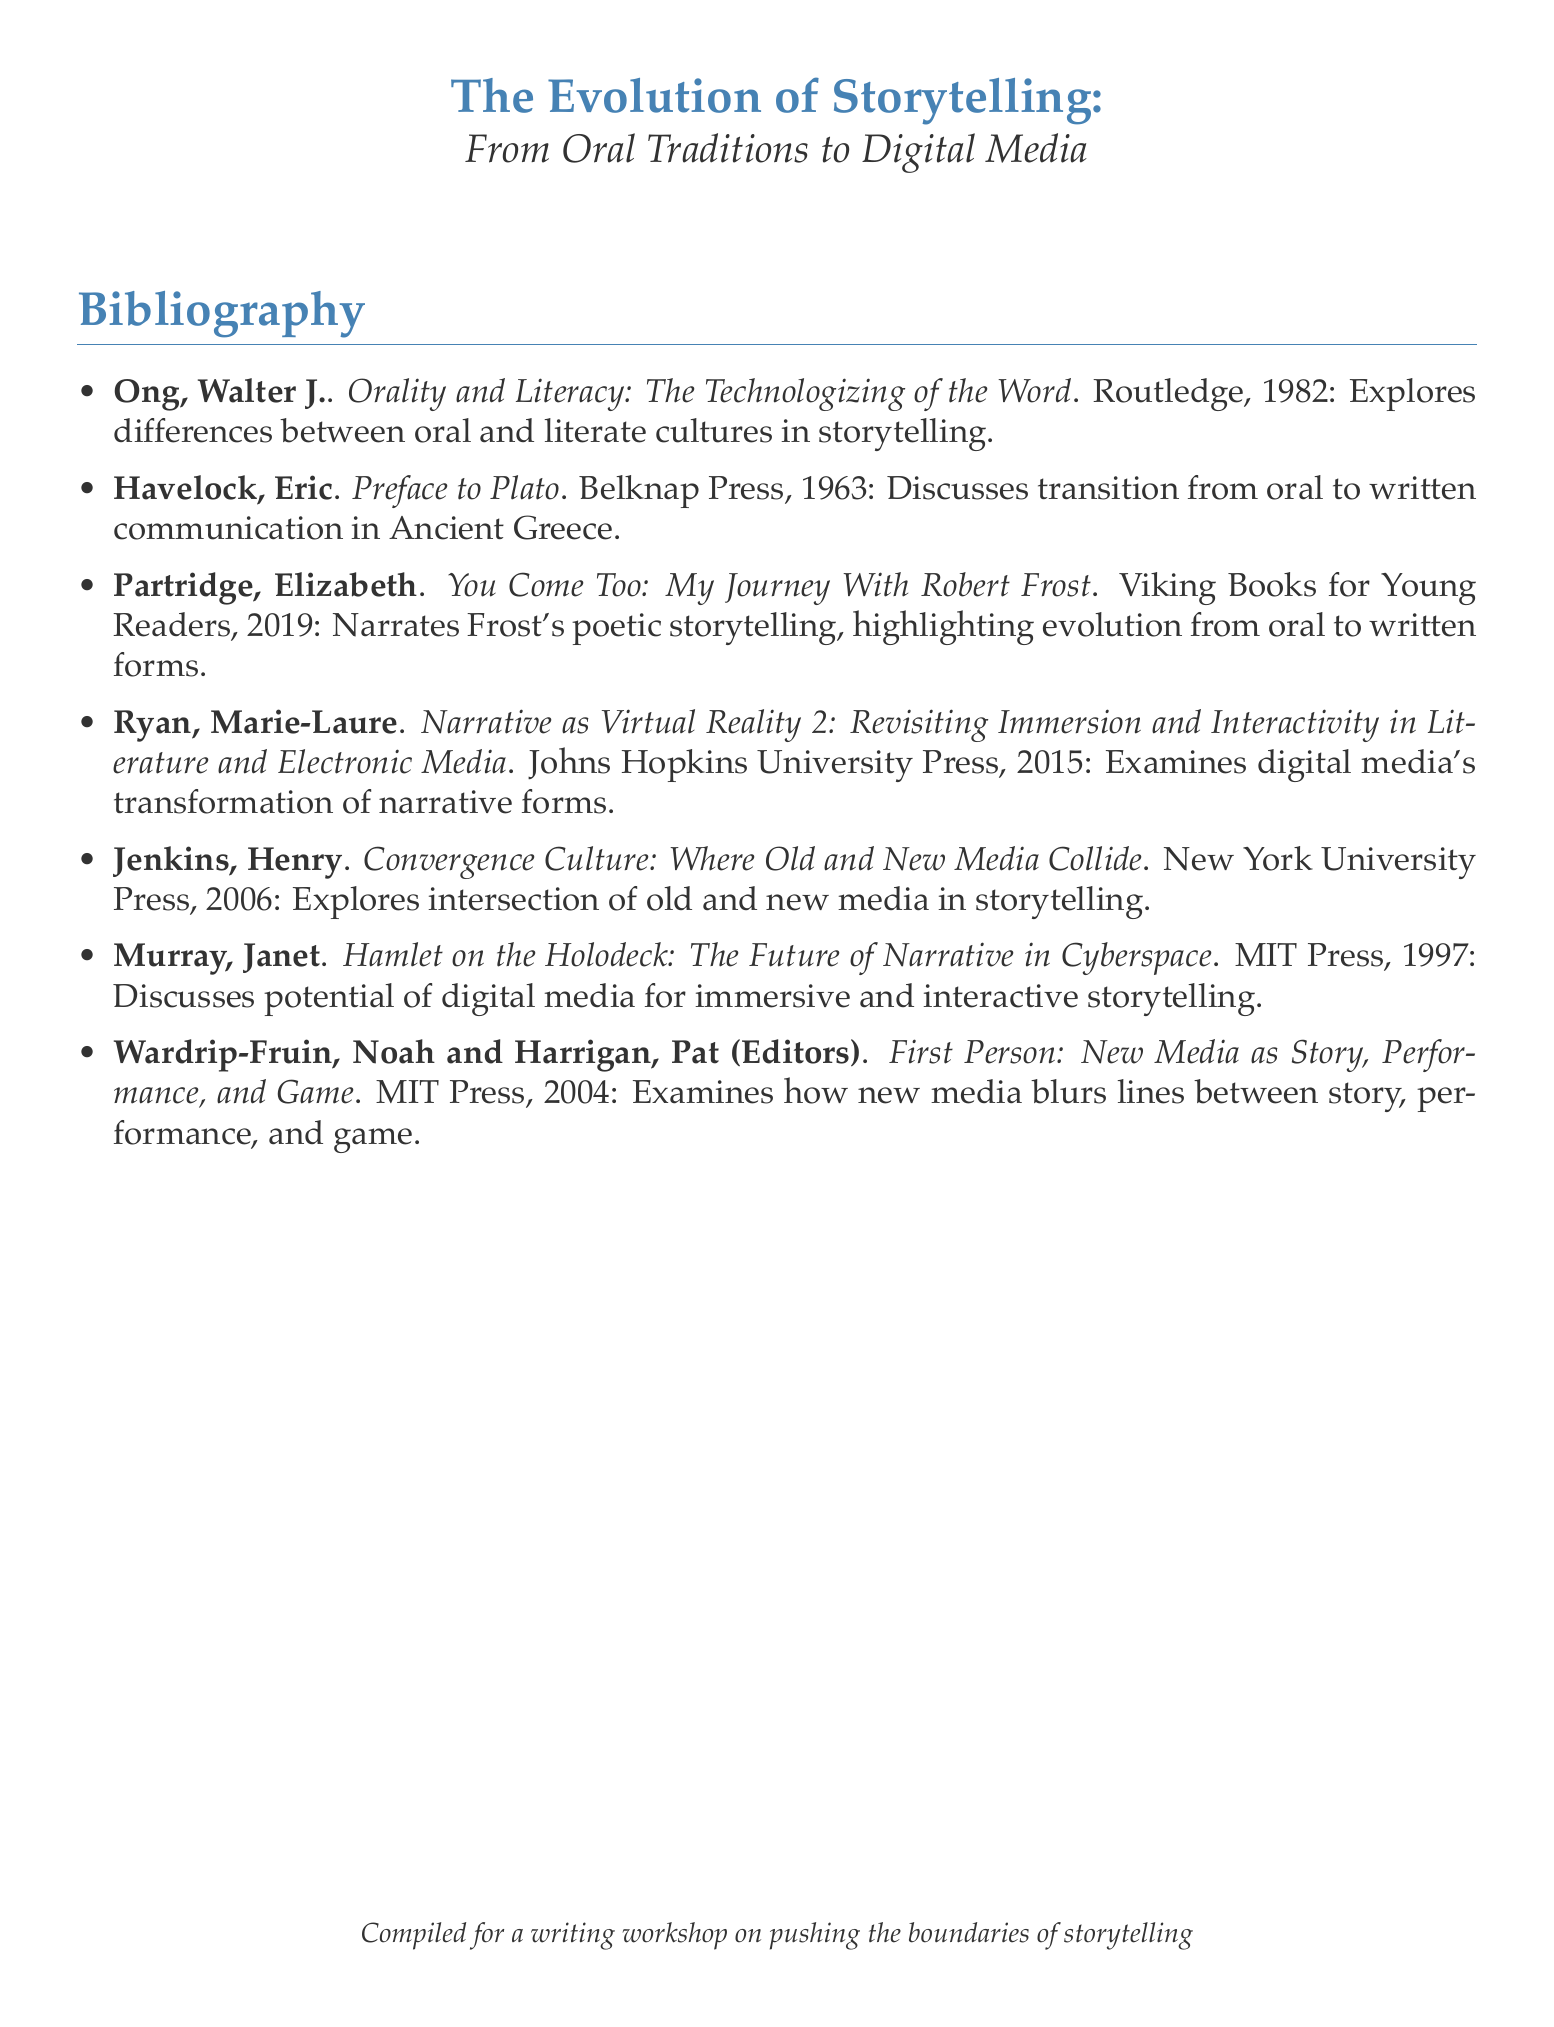What is the title of the first entry? The title of the first entry is found at the beginning of the reference for Walter J. Ong's work.
Answer: Orality and Literacy: The Technologizing of the Word Who is the author of "Narrative as Virtual Reality 2"? The author is identified as Marie-Laure Ryan in the bibliography.
Answer: Marie-Laure Ryan What year was "Convergence Culture" published? The publication year of Henry Jenkins' book is included in the citation.
Answer: 2006 Which publisher released "You Come Too: My Journey With Robert Frost"? The publisher's name is stated in Elizabeth Partridge's entry.
Answer: Viking Books for Young Readers How many entries are listed in the bibliography? The total entries can be counted directly from the list of citations provided.
Answer: 7 What is the main theme explored in "Hamlet on the Holodeck"? The main theme is mentioned in the description of Janet Murray's work.
Answer: Immersive and interactive storytelling Which entry discusses the transition from oral to written communication? The entry discusses the relevant theme in the context of Ancient Greece.
Answer: Preface to Plato What is the main focus of the book edited by Wardrip-Fruin and Harrigan? The focus is described in a way that indicates the blurring of traditional boundaries.
Answer: New media as story, performance, and game 